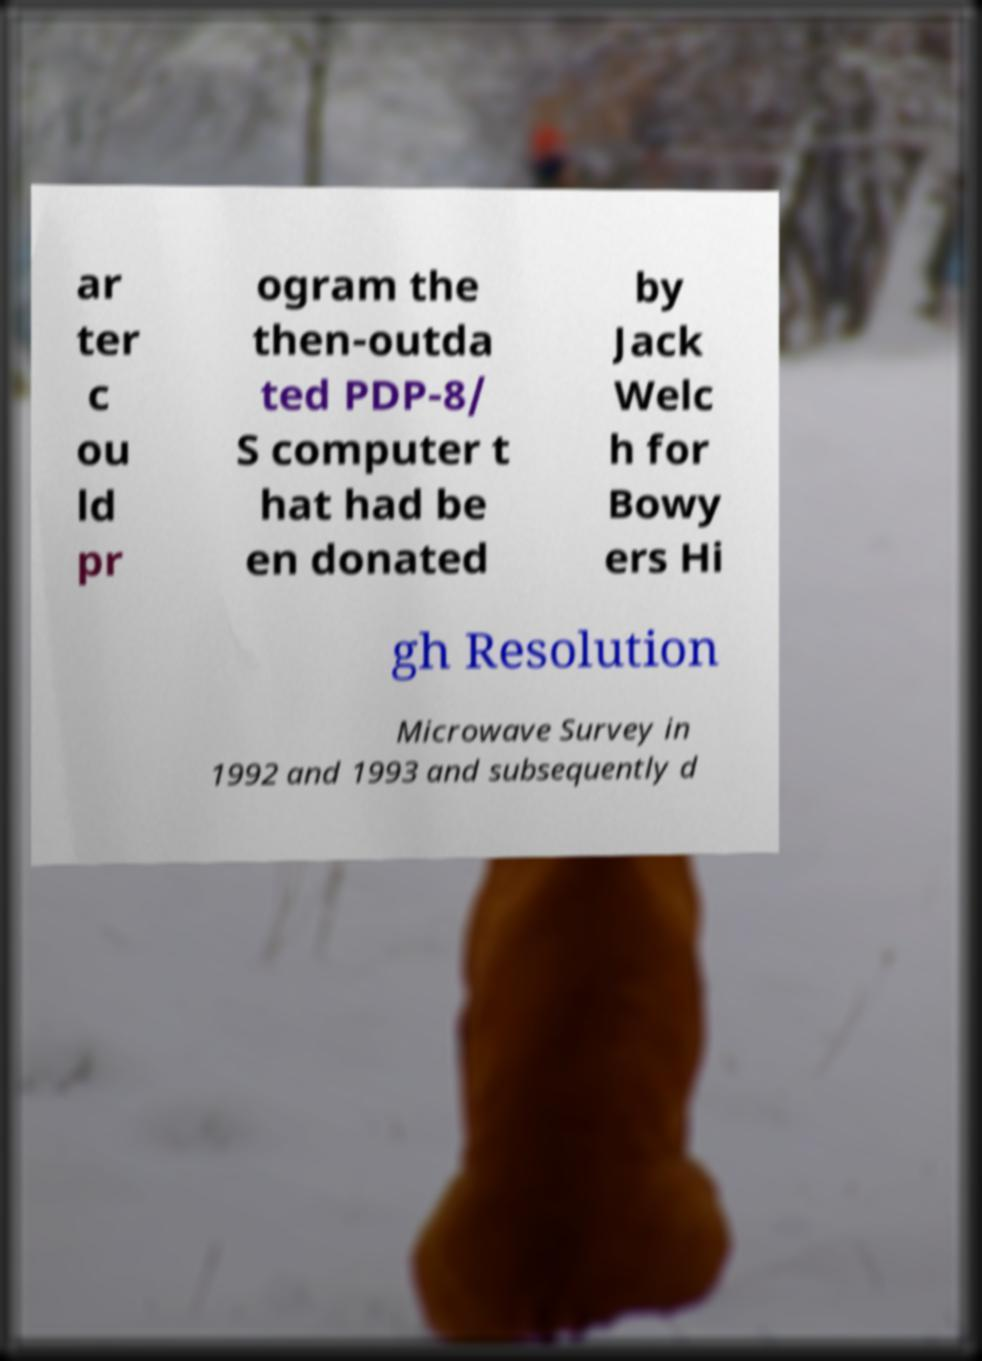Please read and relay the text visible in this image. What does it say? ar ter c ou ld pr ogram the then-outda ted PDP-8/ S computer t hat had be en donated by Jack Welc h for Bowy ers Hi gh Resolution Microwave Survey in 1992 and 1993 and subsequently d 